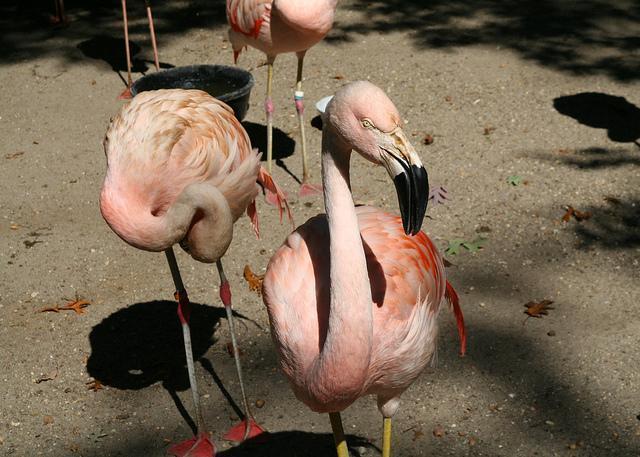How many flamingos are here?
Give a very brief answer. 3. How many birds are visible?
Give a very brief answer. 3. 